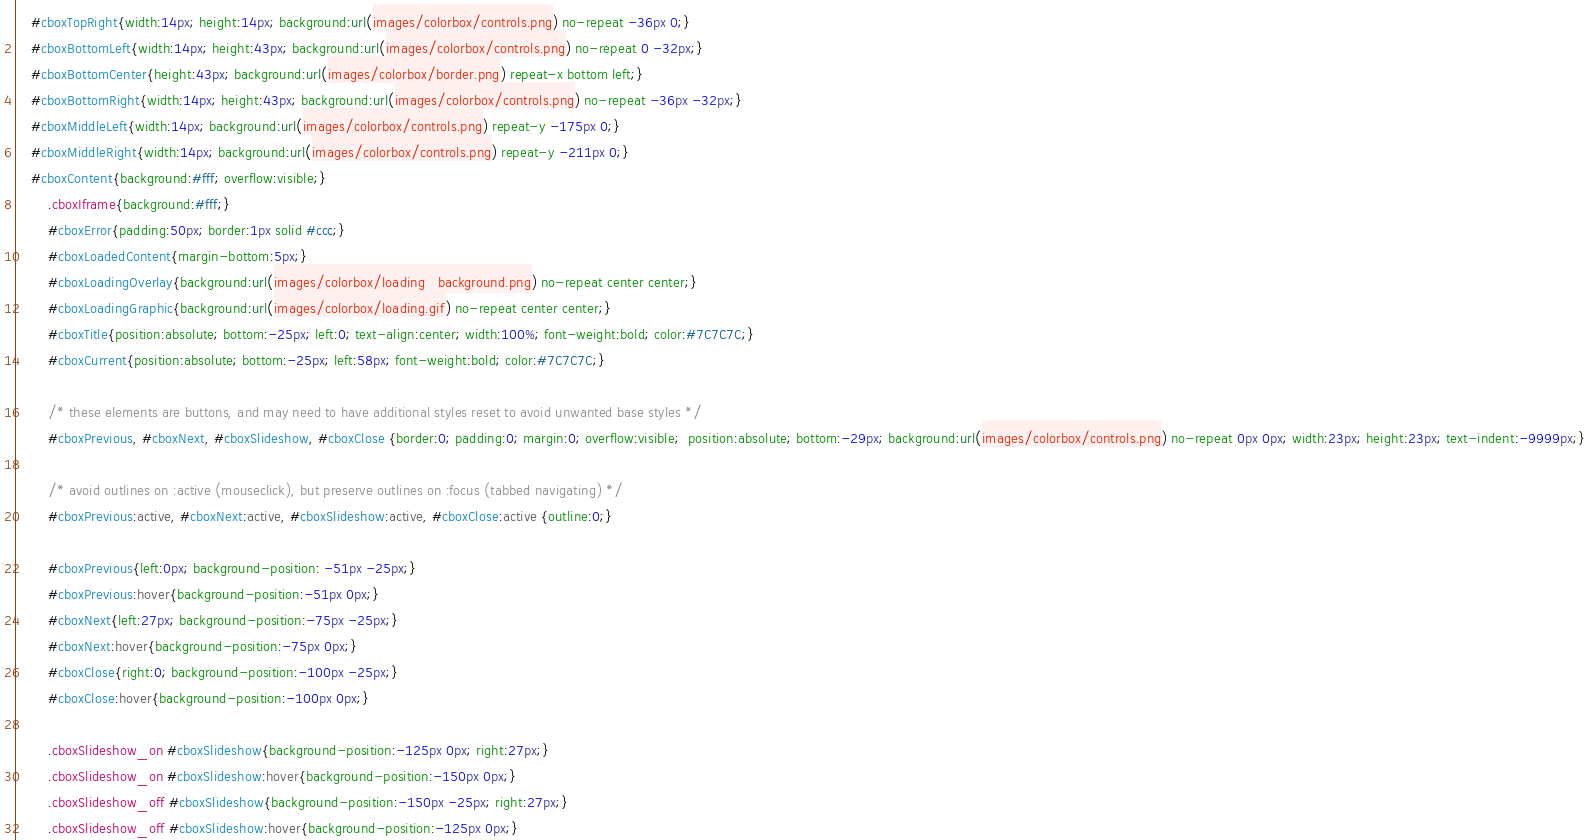<code> <loc_0><loc_0><loc_500><loc_500><_CSS_>    #cboxTopRight{width:14px; height:14px; background:url(images/colorbox/controls.png) no-repeat -36px 0;}
    #cboxBottomLeft{width:14px; height:43px; background:url(images/colorbox/controls.png) no-repeat 0 -32px;}
    #cboxBottomCenter{height:43px; background:url(images/colorbox/border.png) repeat-x bottom left;}
    #cboxBottomRight{width:14px; height:43px; background:url(images/colorbox/controls.png) no-repeat -36px -32px;}
    #cboxMiddleLeft{width:14px; background:url(images/colorbox/controls.png) repeat-y -175px 0;}
    #cboxMiddleRight{width:14px; background:url(images/colorbox/controls.png) repeat-y -211px 0;}
    #cboxContent{background:#fff; overflow:visible;}
        .cboxIframe{background:#fff;}
        #cboxError{padding:50px; border:1px solid #ccc;}
        #cboxLoadedContent{margin-bottom:5px;}
        #cboxLoadingOverlay{background:url(images/colorbox/loading_background.png) no-repeat center center;}
        #cboxLoadingGraphic{background:url(images/colorbox/loading.gif) no-repeat center center;}
        #cboxTitle{position:absolute; bottom:-25px; left:0; text-align:center; width:100%; font-weight:bold; color:#7C7C7C;}
        #cboxCurrent{position:absolute; bottom:-25px; left:58px; font-weight:bold; color:#7C7C7C;}

        /* these elements are buttons, and may need to have additional styles reset to avoid unwanted base styles */
        #cboxPrevious, #cboxNext, #cboxSlideshow, #cboxClose {border:0; padding:0; margin:0; overflow:visible;  position:absolute; bottom:-29px; background:url(images/colorbox/controls.png) no-repeat 0px 0px; width:23px; height:23px; text-indent:-9999px;}
        
        /* avoid outlines on :active (mouseclick), but preserve outlines on :focus (tabbed navigating) */
        #cboxPrevious:active, #cboxNext:active, #cboxSlideshow:active, #cboxClose:active {outline:0;}

        #cboxPrevious{left:0px; background-position: -51px -25px;}
        #cboxPrevious:hover{background-position:-51px 0px;}
        #cboxNext{left:27px; background-position:-75px -25px;}
        #cboxNext:hover{background-position:-75px 0px;}
        #cboxClose{right:0; background-position:-100px -25px;}
        #cboxClose:hover{background-position:-100px 0px;}

        .cboxSlideshow_on #cboxSlideshow{background-position:-125px 0px; right:27px;}
        .cboxSlideshow_on #cboxSlideshow:hover{background-position:-150px 0px;}
        .cboxSlideshow_off #cboxSlideshow{background-position:-150px -25px; right:27px;}
        .cboxSlideshow_off #cboxSlideshow:hover{background-position:-125px 0px;}</code> 